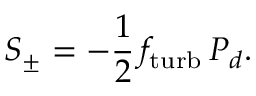Convert formula to latex. <formula><loc_0><loc_0><loc_500><loc_500>S _ { \pm } = - \frac { 1 } { 2 } \, f _ { t u r b } \, P _ { d } .</formula> 